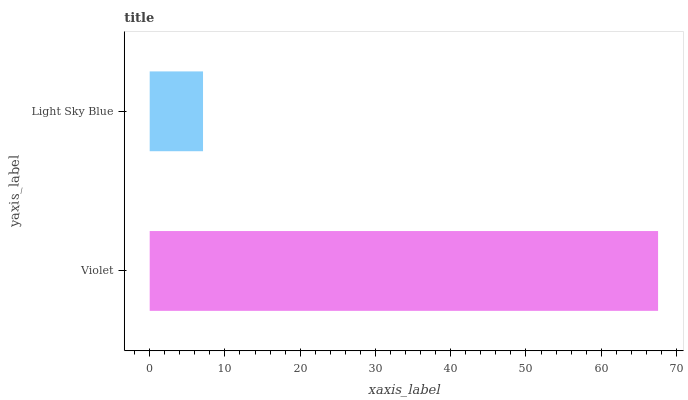Is Light Sky Blue the minimum?
Answer yes or no. Yes. Is Violet the maximum?
Answer yes or no. Yes. Is Light Sky Blue the maximum?
Answer yes or no. No. Is Violet greater than Light Sky Blue?
Answer yes or no. Yes. Is Light Sky Blue less than Violet?
Answer yes or no. Yes. Is Light Sky Blue greater than Violet?
Answer yes or no. No. Is Violet less than Light Sky Blue?
Answer yes or no. No. Is Violet the high median?
Answer yes or no. Yes. Is Light Sky Blue the low median?
Answer yes or no. Yes. Is Light Sky Blue the high median?
Answer yes or no. No. Is Violet the low median?
Answer yes or no. No. 